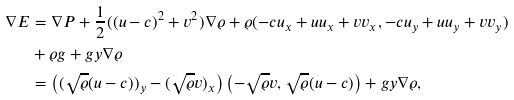<formula> <loc_0><loc_0><loc_500><loc_500>\nabla E & = \nabla P + \frac { 1 } { 2 } ( ( u - c ) ^ { 2 } + v ^ { 2 } ) \nabla \varrho + \varrho ( - c u _ { x } + u u _ { x } + v v _ { x } , - c u _ { y } + u u _ { y } + v v _ { y } ) \\ & + \varrho g + g y \nabla \varrho \\ & = \left ( ( \sqrt { \varrho } ( u - c ) ) _ { y } - ( \sqrt { \varrho } v ) _ { x } \right ) \left ( - \sqrt { \varrho } v , \sqrt { \varrho } ( u - c ) \right ) + g y \nabla \varrho ,</formula> 